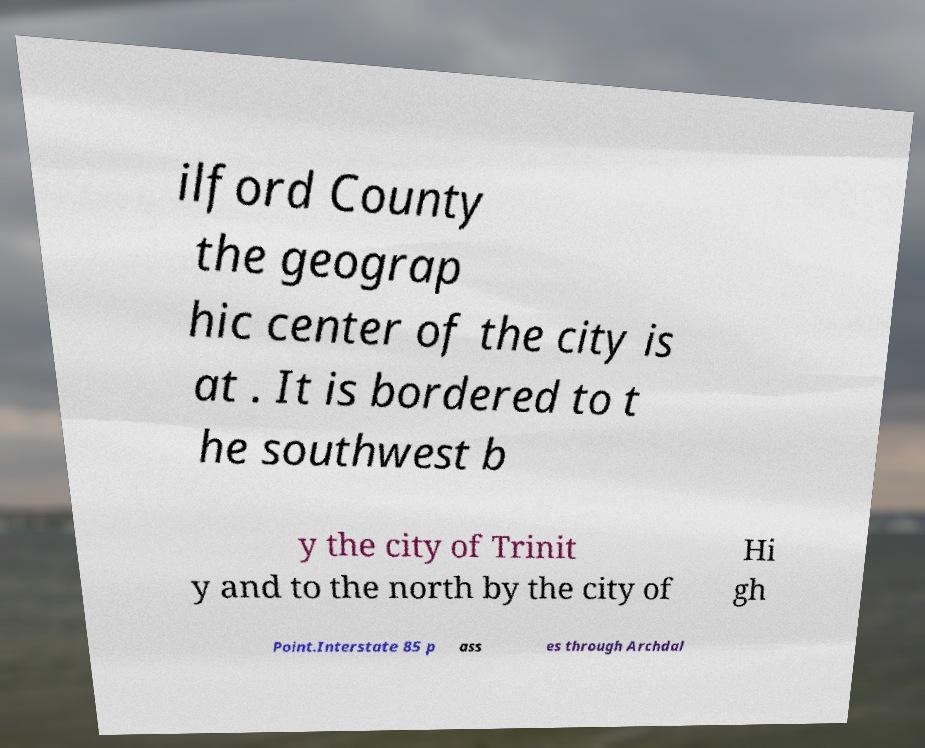Could you assist in decoding the text presented in this image and type it out clearly? ilford County the geograp hic center of the city is at . It is bordered to t he southwest b y the city of Trinit y and to the north by the city of Hi gh Point.Interstate 85 p ass es through Archdal 